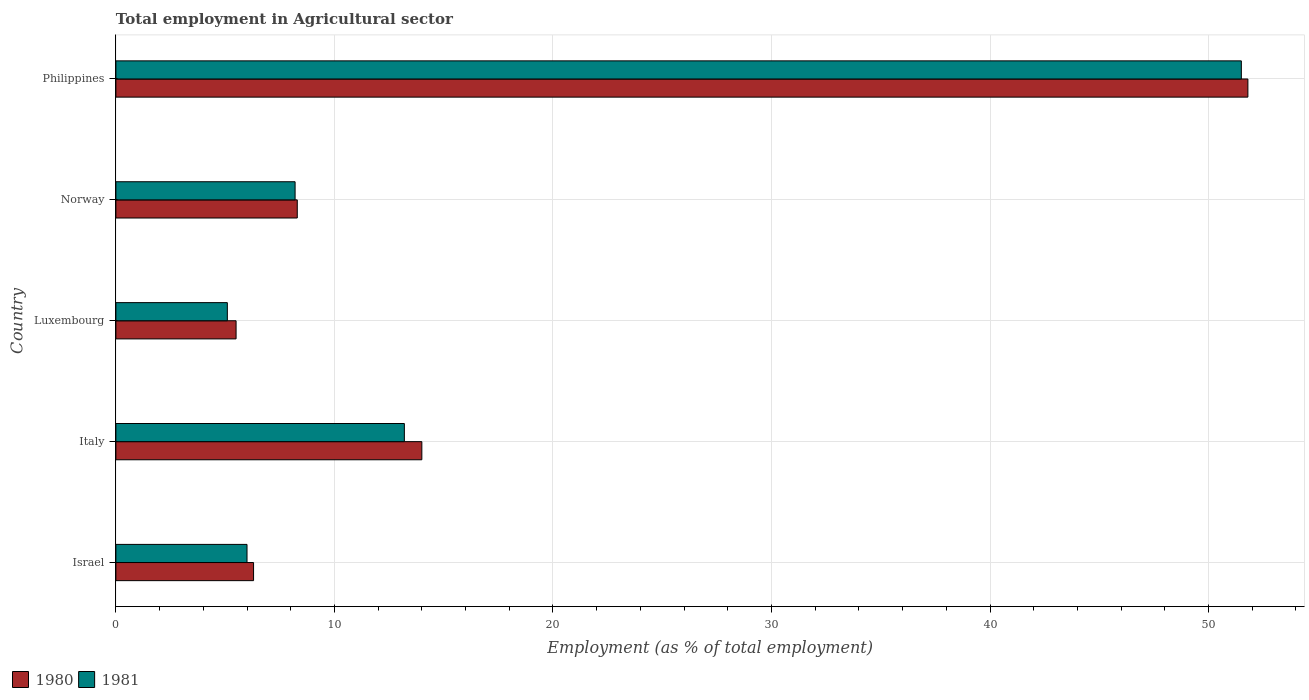Are the number of bars per tick equal to the number of legend labels?
Keep it short and to the point. Yes. In how many cases, is the number of bars for a given country not equal to the number of legend labels?
Offer a terse response. 0. What is the employment in agricultural sector in 1981 in Italy?
Give a very brief answer. 13.2. Across all countries, what is the maximum employment in agricultural sector in 1980?
Your answer should be compact. 51.8. Across all countries, what is the minimum employment in agricultural sector in 1980?
Provide a short and direct response. 5.5. In which country was the employment in agricultural sector in 1980 minimum?
Ensure brevity in your answer.  Luxembourg. What is the total employment in agricultural sector in 1981 in the graph?
Give a very brief answer. 84. What is the difference between the employment in agricultural sector in 1980 in Luxembourg and that in Philippines?
Offer a very short reply. -46.3. What is the difference between the employment in agricultural sector in 1980 in Luxembourg and the employment in agricultural sector in 1981 in Italy?
Provide a succinct answer. -7.7. What is the average employment in agricultural sector in 1981 per country?
Provide a succinct answer. 16.8. What is the difference between the employment in agricultural sector in 1980 and employment in agricultural sector in 1981 in Norway?
Provide a short and direct response. 0.1. What is the ratio of the employment in agricultural sector in 1981 in Italy to that in Luxembourg?
Give a very brief answer. 2.59. Is the employment in agricultural sector in 1980 in Luxembourg less than that in Norway?
Offer a very short reply. Yes. Is the difference between the employment in agricultural sector in 1980 in Norway and Philippines greater than the difference between the employment in agricultural sector in 1981 in Norway and Philippines?
Give a very brief answer. No. What is the difference between the highest and the second highest employment in agricultural sector in 1980?
Your answer should be very brief. 37.8. What is the difference between the highest and the lowest employment in agricultural sector in 1981?
Provide a short and direct response. 46.4. In how many countries, is the employment in agricultural sector in 1981 greater than the average employment in agricultural sector in 1981 taken over all countries?
Provide a succinct answer. 1. Is the sum of the employment in agricultural sector in 1980 in Luxembourg and Norway greater than the maximum employment in agricultural sector in 1981 across all countries?
Provide a short and direct response. No. What does the 2nd bar from the bottom in Italy represents?
Provide a short and direct response. 1981. Are all the bars in the graph horizontal?
Ensure brevity in your answer.  Yes. What is the difference between two consecutive major ticks on the X-axis?
Provide a short and direct response. 10. Are the values on the major ticks of X-axis written in scientific E-notation?
Offer a terse response. No. Does the graph contain any zero values?
Your response must be concise. No. Does the graph contain grids?
Make the answer very short. Yes. How many legend labels are there?
Make the answer very short. 2. What is the title of the graph?
Provide a short and direct response. Total employment in Agricultural sector. Does "1995" appear as one of the legend labels in the graph?
Keep it short and to the point. No. What is the label or title of the X-axis?
Your response must be concise. Employment (as % of total employment). What is the label or title of the Y-axis?
Offer a terse response. Country. What is the Employment (as % of total employment) of 1980 in Israel?
Provide a succinct answer. 6.3. What is the Employment (as % of total employment) of 1981 in Israel?
Keep it short and to the point. 6. What is the Employment (as % of total employment) in 1981 in Italy?
Offer a terse response. 13.2. What is the Employment (as % of total employment) of 1980 in Luxembourg?
Make the answer very short. 5.5. What is the Employment (as % of total employment) in 1981 in Luxembourg?
Your answer should be compact. 5.1. What is the Employment (as % of total employment) in 1980 in Norway?
Your answer should be compact. 8.3. What is the Employment (as % of total employment) in 1981 in Norway?
Provide a short and direct response. 8.2. What is the Employment (as % of total employment) of 1980 in Philippines?
Make the answer very short. 51.8. What is the Employment (as % of total employment) in 1981 in Philippines?
Ensure brevity in your answer.  51.5. Across all countries, what is the maximum Employment (as % of total employment) of 1980?
Your answer should be very brief. 51.8. Across all countries, what is the maximum Employment (as % of total employment) in 1981?
Your answer should be compact. 51.5. Across all countries, what is the minimum Employment (as % of total employment) of 1980?
Provide a succinct answer. 5.5. Across all countries, what is the minimum Employment (as % of total employment) of 1981?
Offer a terse response. 5.1. What is the total Employment (as % of total employment) in 1980 in the graph?
Provide a succinct answer. 85.9. What is the total Employment (as % of total employment) of 1981 in the graph?
Keep it short and to the point. 84. What is the difference between the Employment (as % of total employment) in 1981 in Israel and that in Italy?
Make the answer very short. -7.2. What is the difference between the Employment (as % of total employment) in 1980 in Israel and that in Luxembourg?
Keep it short and to the point. 0.8. What is the difference between the Employment (as % of total employment) in 1980 in Israel and that in Norway?
Offer a very short reply. -2. What is the difference between the Employment (as % of total employment) in 1980 in Israel and that in Philippines?
Your response must be concise. -45.5. What is the difference between the Employment (as % of total employment) of 1981 in Israel and that in Philippines?
Make the answer very short. -45.5. What is the difference between the Employment (as % of total employment) of 1981 in Italy and that in Luxembourg?
Your answer should be compact. 8.1. What is the difference between the Employment (as % of total employment) of 1980 in Italy and that in Philippines?
Your response must be concise. -37.8. What is the difference between the Employment (as % of total employment) of 1981 in Italy and that in Philippines?
Offer a terse response. -38.3. What is the difference between the Employment (as % of total employment) of 1980 in Luxembourg and that in Norway?
Provide a short and direct response. -2.8. What is the difference between the Employment (as % of total employment) of 1980 in Luxembourg and that in Philippines?
Your answer should be compact. -46.3. What is the difference between the Employment (as % of total employment) of 1981 in Luxembourg and that in Philippines?
Offer a very short reply. -46.4. What is the difference between the Employment (as % of total employment) of 1980 in Norway and that in Philippines?
Provide a succinct answer. -43.5. What is the difference between the Employment (as % of total employment) in 1981 in Norway and that in Philippines?
Keep it short and to the point. -43.3. What is the difference between the Employment (as % of total employment) of 1980 in Israel and the Employment (as % of total employment) of 1981 in Luxembourg?
Keep it short and to the point. 1.2. What is the difference between the Employment (as % of total employment) in 1980 in Israel and the Employment (as % of total employment) in 1981 in Norway?
Your answer should be compact. -1.9. What is the difference between the Employment (as % of total employment) of 1980 in Israel and the Employment (as % of total employment) of 1981 in Philippines?
Offer a terse response. -45.2. What is the difference between the Employment (as % of total employment) of 1980 in Italy and the Employment (as % of total employment) of 1981 in Luxembourg?
Keep it short and to the point. 8.9. What is the difference between the Employment (as % of total employment) in 1980 in Italy and the Employment (as % of total employment) in 1981 in Philippines?
Make the answer very short. -37.5. What is the difference between the Employment (as % of total employment) in 1980 in Luxembourg and the Employment (as % of total employment) in 1981 in Norway?
Provide a short and direct response. -2.7. What is the difference between the Employment (as % of total employment) of 1980 in Luxembourg and the Employment (as % of total employment) of 1981 in Philippines?
Offer a very short reply. -46. What is the difference between the Employment (as % of total employment) of 1980 in Norway and the Employment (as % of total employment) of 1981 in Philippines?
Offer a terse response. -43.2. What is the average Employment (as % of total employment) in 1980 per country?
Ensure brevity in your answer.  17.18. What is the average Employment (as % of total employment) of 1981 per country?
Offer a very short reply. 16.8. What is the difference between the Employment (as % of total employment) in 1980 and Employment (as % of total employment) in 1981 in Israel?
Your answer should be compact. 0.3. What is the difference between the Employment (as % of total employment) of 1980 and Employment (as % of total employment) of 1981 in Italy?
Your answer should be compact. 0.8. What is the difference between the Employment (as % of total employment) of 1980 and Employment (as % of total employment) of 1981 in Luxembourg?
Provide a short and direct response. 0.4. What is the difference between the Employment (as % of total employment) in 1980 and Employment (as % of total employment) in 1981 in Norway?
Keep it short and to the point. 0.1. What is the ratio of the Employment (as % of total employment) of 1980 in Israel to that in Italy?
Offer a terse response. 0.45. What is the ratio of the Employment (as % of total employment) in 1981 in Israel to that in Italy?
Offer a terse response. 0.45. What is the ratio of the Employment (as % of total employment) of 1980 in Israel to that in Luxembourg?
Your answer should be very brief. 1.15. What is the ratio of the Employment (as % of total employment) in 1981 in Israel to that in Luxembourg?
Offer a very short reply. 1.18. What is the ratio of the Employment (as % of total employment) in 1980 in Israel to that in Norway?
Make the answer very short. 0.76. What is the ratio of the Employment (as % of total employment) in 1981 in Israel to that in Norway?
Your answer should be compact. 0.73. What is the ratio of the Employment (as % of total employment) of 1980 in Israel to that in Philippines?
Give a very brief answer. 0.12. What is the ratio of the Employment (as % of total employment) in 1981 in Israel to that in Philippines?
Your response must be concise. 0.12. What is the ratio of the Employment (as % of total employment) in 1980 in Italy to that in Luxembourg?
Give a very brief answer. 2.55. What is the ratio of the Employment (as % of total employment) of 1981 in Italy to that in Luxembourg?
Give a very brief answer. 2.59. What is the ratio of the Employment (as % of total employment) in 1980 in Italy to that in Norway?
Offer a terse response. 1.69. What is the ratio of the Employment (as % of total employment) in 1981 in Italy to that in Norway?
Provide a short and direct response. 1.61. What is the ratio of the Employment (as % of total employment) of 1980 in Italy to that in Philippines?
Offer a terse response. 0.27. What is the ratio of the Employment (as % of total employment) of 1981 in Italy to that in Philippines?
Your answer should be compact. 0.26. What is the ratio of the Employment (as % of total employment) in 1980 in Luxembourg to that in Norway?
Provide a short and direct response. 0.66. What is the ratio of the Employment (as % of total employment) of 1981 in Luxembourg to that in Norway?
Ensure brevity in your answer.  0.62. What is the ratio of the Employment (as % of total employment) in 1980 in Luxembourg to that in Philippines?
Provide a short and direct response. 0.11. What is the ratio of the Employment (as % of total employment) of 1981 in Luxembourg to that in Philippines?
Ensure brevity in your answer.  0.1. What is the ratio of the Employment (as % of total employment) in 1980 in Norway to that in Philippines?
Provide a succinct answer. 0.16. What is the ratio of the Employment (as % of total employment) in 1981 in Norway to that in Philippines?
Your answer should be compact. 0.16. What is the difference between the highest and the second highest Employment (as % of total employment) in 1980?
Your answer should be compact. 37.8. What is the difference between the highest and the second highest Employment (as % of total employment) in 1981?
Make the answer very short. 38.3. What is the difference between the highest and the lowest Employment (as % of total employment) of 1980?
Your response must be concise. 46.3. What is the difference between the highest and the lowest Employment (as % of total employment) of 1981?
Provide a short and direct response. 46.4. 